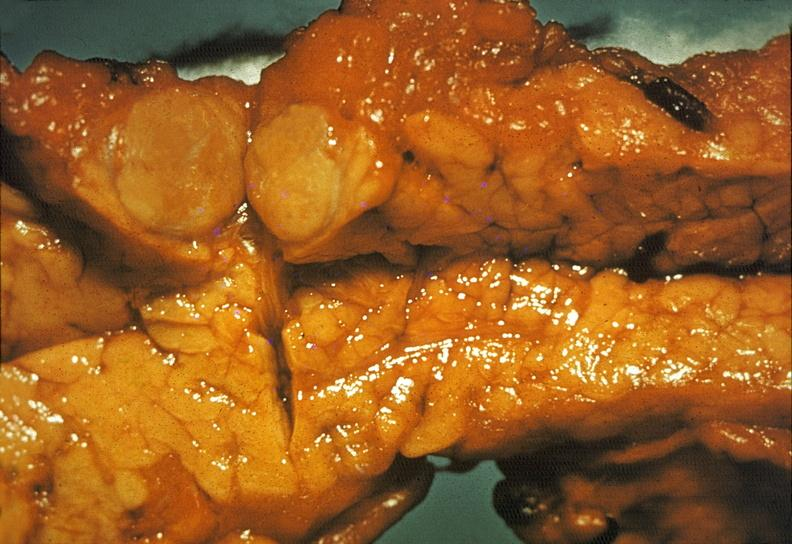does silver show islet cell carcinoma?
Answer the question using a single word or phrase. No 